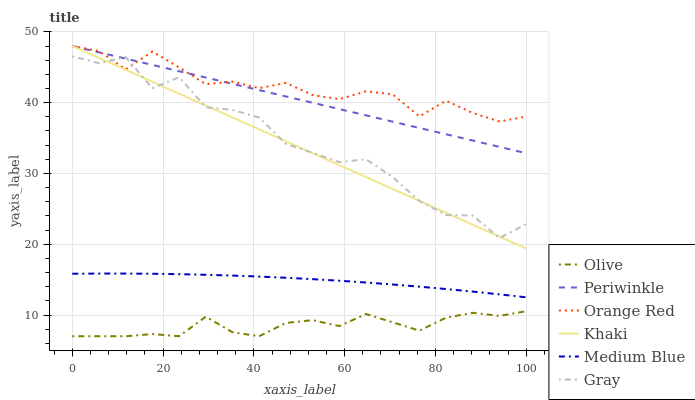Does Olive have the minimum area under the curve?
Answer yes or no. Yes. Does Orange Red have the maximum area under the curve?
Answer yes or no. Yes. Does Khaki have the minimum area under the curve?
Answer yes or no. No. Does Khaki have the maximum area under the curve?
Answer yes or no. No. Is Khaki the smoothest?
Answer yes or no. Yes. Is Gray the roughest?
Answer yes or no. Yes. Is Medium Blue the smoothest?
Answer yes or no. No. Is Medium Blue the roughest?
Answer yes or no. No. Does Olive have the lowest value?
Answer yes or no. Yes. Does Khaki have the lowest value?
Answer yes or no. No. Does Orange Red have the highest value?
Answer yes or no. Yes. Does Medium Blue have the highest value?
Answer yes or no. No. Is Olive less than Periwinkle?
Answer yes or no. Yes. Is Periwinkle greater than Olive?
Answer yes or no. Yes. Does Periwinkle intersect Gray?
Answer yes or no. Yes. Is Periwinkle less than Gray?
Answer yes or no. No. Is Periwinkle greater than Gray?
Answer yes or no. No. Does Olive intersect Periwinkle?
Answer yes or no. No. 